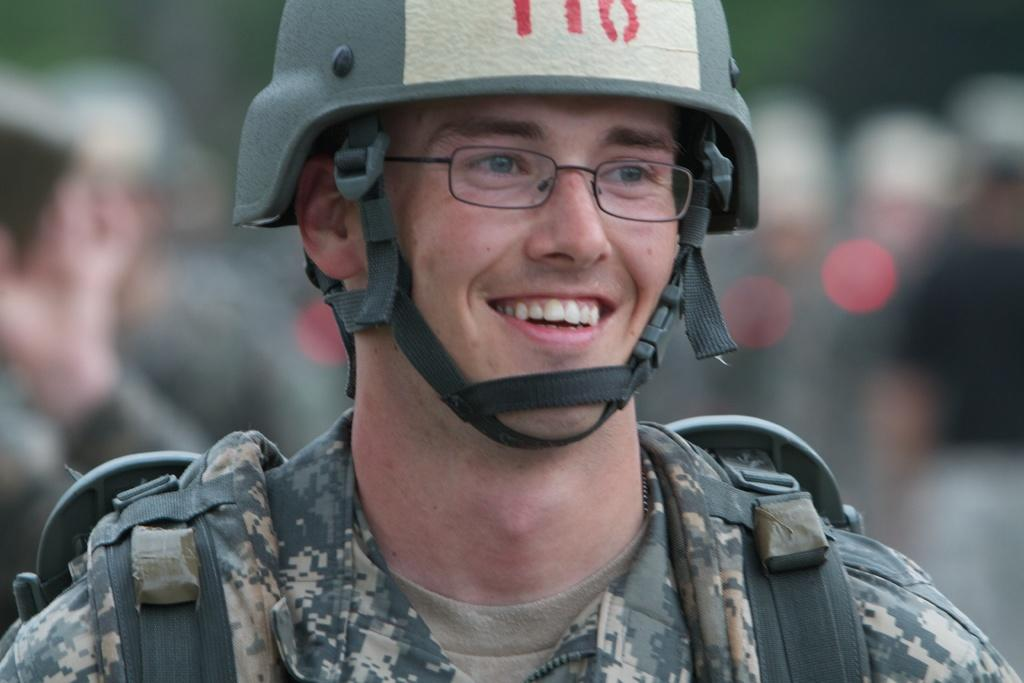Who is present in the image? There is a man in the image. What is the man doing in the image? The man is smiling in the image. What accessories is the man wearing? The man is wearing spectacles and a helmet in the image. Can you describe the background of the image? The background of the image is blurred. What type of loaf is the man holding in the image? There is no loaf present in the image; the man is wearing a helmet and spectacles. Can you see any seeds in the image? There are no seeds visible in the image. 